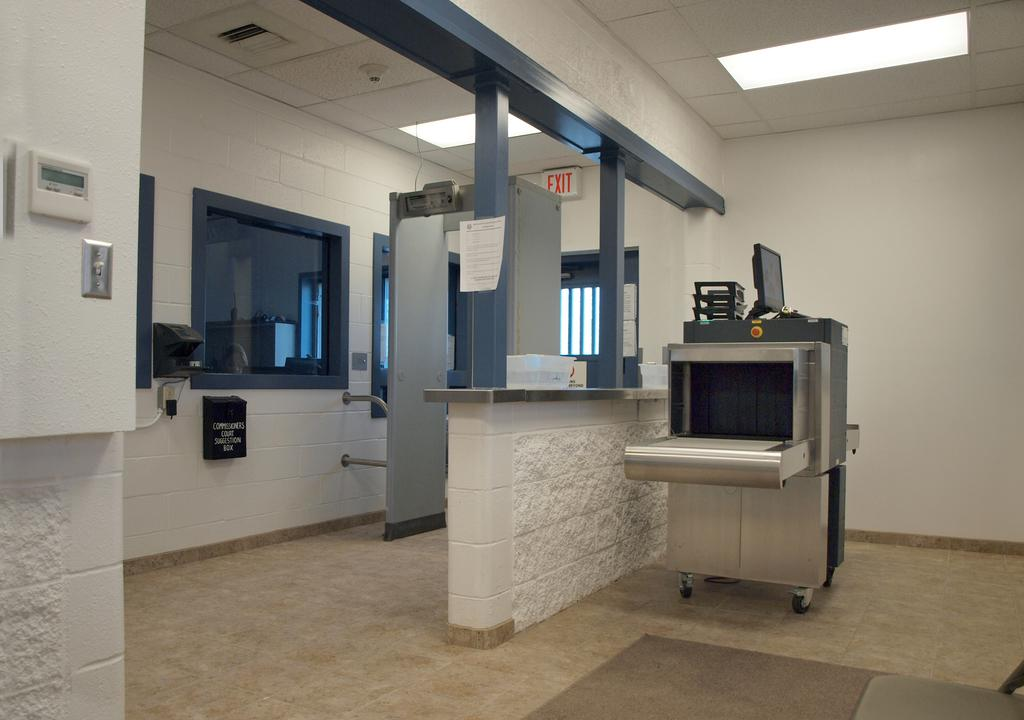<image>
Relay a brief, clear account of the picture shown. A red EXIT sign is mounted above a doorway behind a metal detector. 